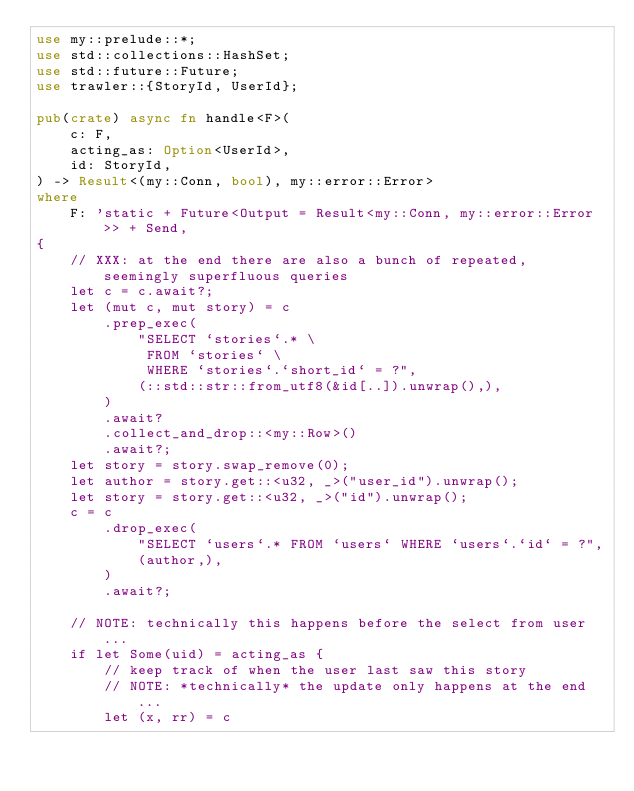<code> <loc_0><loc_0><loc_500><loc_500><_Rust_>use my::prelude::*;
use std::collections::HashSet;
use std::future::Future;
use trawler::{StoryId, UserId};

pub(crate) async fn handle<F>(
    c: F,
    acting_as: Option<UserId>,
    id: StoryId,
) -> Result<(my::Conn, bool), my::error::Error>
where
    F: 'static + Future<Output = Result<my::Conn, my::error::Error>> + Send,
{
    // XXX: at the end there are also a bunch of repeated, seemingly superfluous queries
    let c = c.await?;
    let (mut c, mut story) = c
        .prep_exec(
            "SELECT `stories`.* \
             FROM `stories` \
             WHERE `stories`.`short_id` = ?",
            (::std::str::from_utf8(&id[..]).unwrap(),),
        )
        .await?
        .collect_and_drop::<my::Row>()
        .await?;
    let story = story.swap_remove(0);
    let author = story.get::<u32, _>("user_id").unwrap();
    let story = story.get::<u32, _>("id").unwrap();
    c = c
        .drop_exec(
            "SELECT `users`.* FROM `users` WHERE `users`.`id` = ?",
            (author,),
        )
        .await?;

    // NOTE: technically this happens before the select from user...
    if let Some(uid) = acting_as {
        // keep track of when the user last saw this story
        // NOTE: *technically* the update only happens at the end...
        let (x, rr) = c</code> 